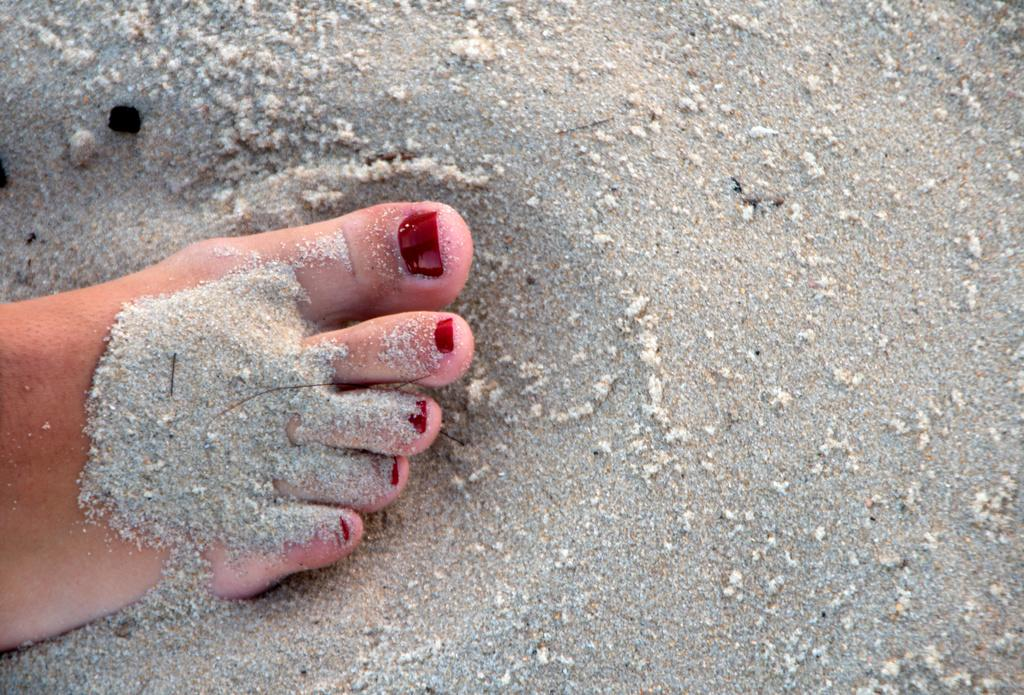What part of a person's body can be seen in the image? There is a person's leg in the image. What is the color of the sand in the image? The sand in the image is gray in color. Where is the garden located in the image? There is no garden present in the image. What activity is taking place during the recess in the image? There is no recess or any indication of an activity taking place in the image. 